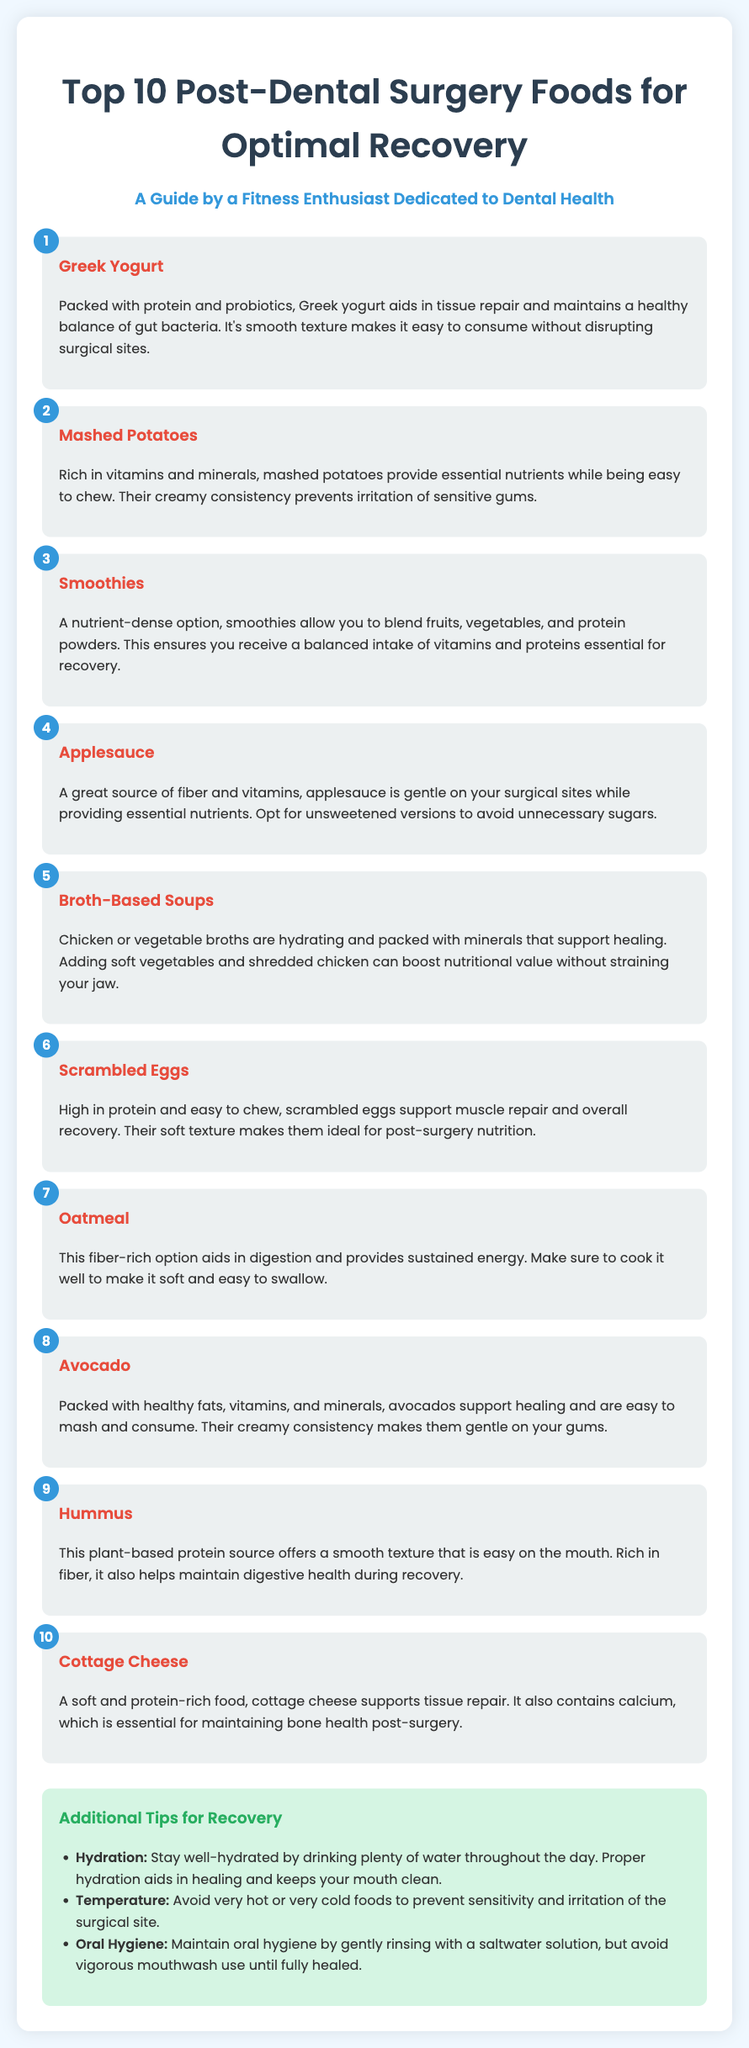What is the first food recommended? The first food listed in the document is Greek yogurt, which is mentioned as the top choice for post-dental surgery recovery.
Answer: Greek Yogurt What ranking does mashed potatoes receive? Mashed potatoes are listed as the second item in the ranking of post-dental surgery foods in the document.
Answer: 2 Which food is described as high in protein and easy to chew? The document describes scrambled eggs as high in protein and easy to chew, making them suitable for post-surgery nutrition.
Answer: Scrambled Eggs What is suggested to avoid to prevent irritation of the surgical site? The document suggests avoiding very hot or very cold foods to prevent sensitivity and irritation of the surgical site in the recovery tips section.
Answer: Very hot or very cold foods Which food is recommended for its creamy consistency? Foods that are highlighted for their creamy consistency in the document include avocado and Greek yogurt, both of which are suitable for post-surgery diets.
Answer: Avocado and Greek Yogurt How many foods are listed in total for optimal recovery? The document specifically outlines a list that consists of ten foods recommended for optimal recovery after dental surgery.
Answer: 10 What is the main benefit of oatmeal mentioned? The document mentions that oatmeal is a fiber-rich option which aids in digestion and provides sustained energy, supporting the recovery process.
Answer: Aids in digestion What additional nutrient does cottage cheese provide? Cottage cheese is noted to contain calcium, which is essential for maintaining bone health post-surgery according to the document.
Answer: Calcium 